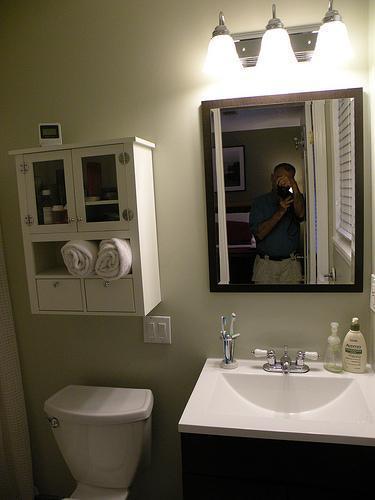How many people are visible?
Give a very brief answer. 1. 